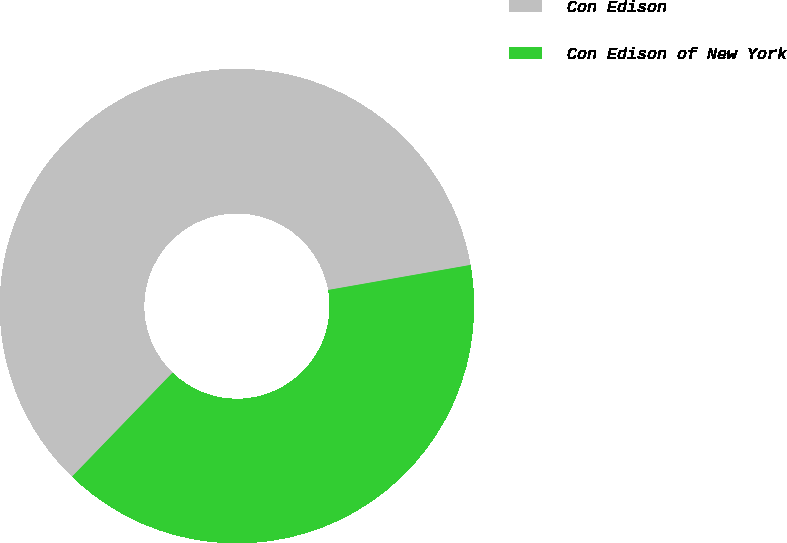Convert chart to OTSL. <chart><loc_0><loc_0><loc_500><loc_500><pie_chart><fcel>Con Edison<fcel>Con Edison of New York<nl><fcel>60.0%<fcel>40.0%<nl></chart> 